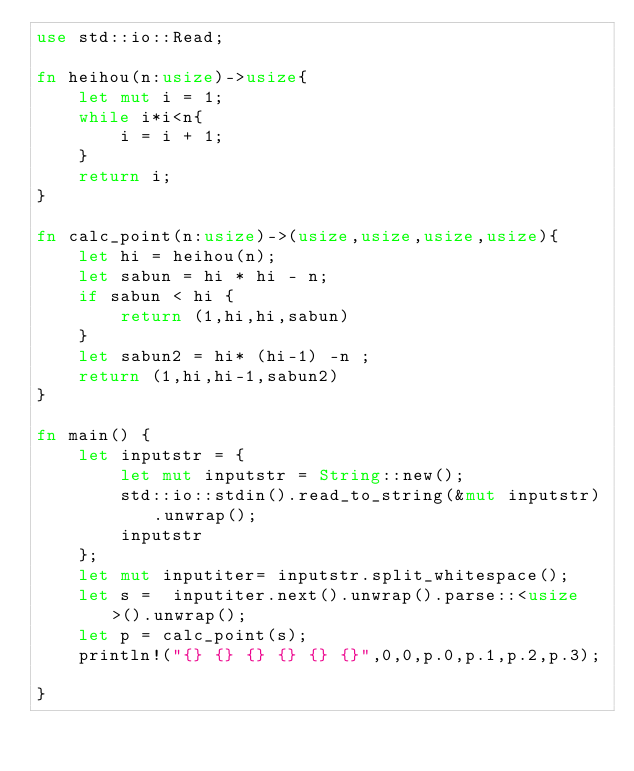<code> <loc_0><loc_0><loc_500><loc_500><_Rust_>use std::io::Read;

fn heihou(n:usize)->usize{
    let mut i = 1;
    while i*i<n{
        i = i + 1;
    }
    return i;
}

fn calc_point(n:usize)->(usize,usize,usize,usize){
    let hi = heihou(n);
    let sabun = hi * hi - n;
    if sabun < hi {
        return (1,hi,hi,sabun)
    }
    let sabun2 = hi* (hi-1) -n ;
    return (1,hi,hi-1,sabun2)
}

fn main() {
    let inputstr = {
        let mut inputstr = String::new();
        std::io::stdin().read_to_string(&mut inputstr).unwrap();
        inputstr
    };
    let mut inputiter= inputstr.split_whitespace();
    let s =  inputiter.next().unwrap().parse::<usize>().unwrap();
    let p = calc_point(s);
    println!("{} {} {} {} {} {}",0,0,p.0,p.1,p.2,p.3);

}
</code> 